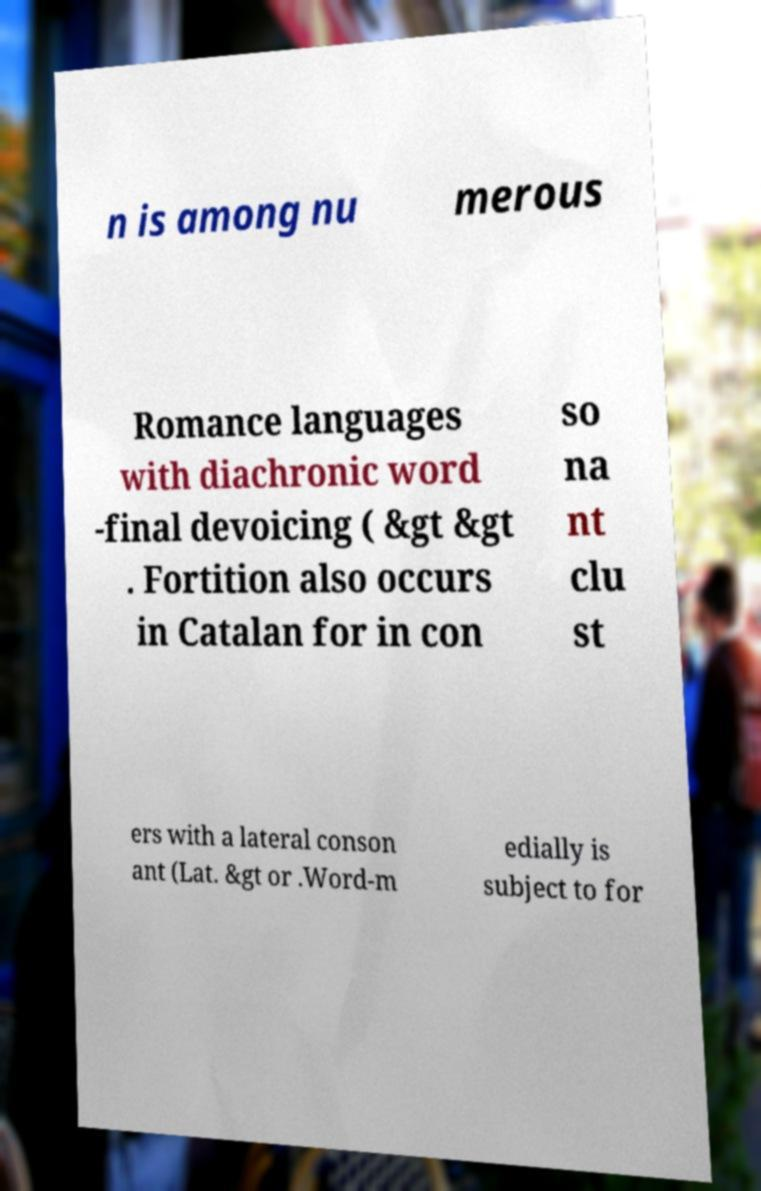Please read and relay the text visible in this image. What does it say? n is among nu merous Romance languages with diachronic word -final devoicing ( &gt &gt . Fortition also occurs in Catalan for in con so na nt clu st ers with a lateral conson ant (Lat. &gt or .Word-m edially is subject to for 